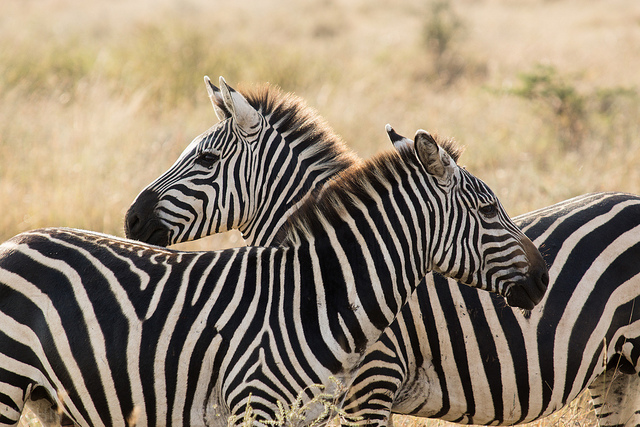Imagine if these zebras could fly, how would they experience their environment? If these zebras could fly, they would experience their environment from a breathtaking new perspective. Soaring above the savannah, they'd see vast herds of wildebeest and antelope migrating, watch lions prowling through the grass, and marvel at the intricate patterns of rivers and watering holes below. The wind rushing through their manes and the freedom to explore their territory from the sky would fundamentally change their relationship with their land, offering them safety from predators and the ability to find resources more easily. 